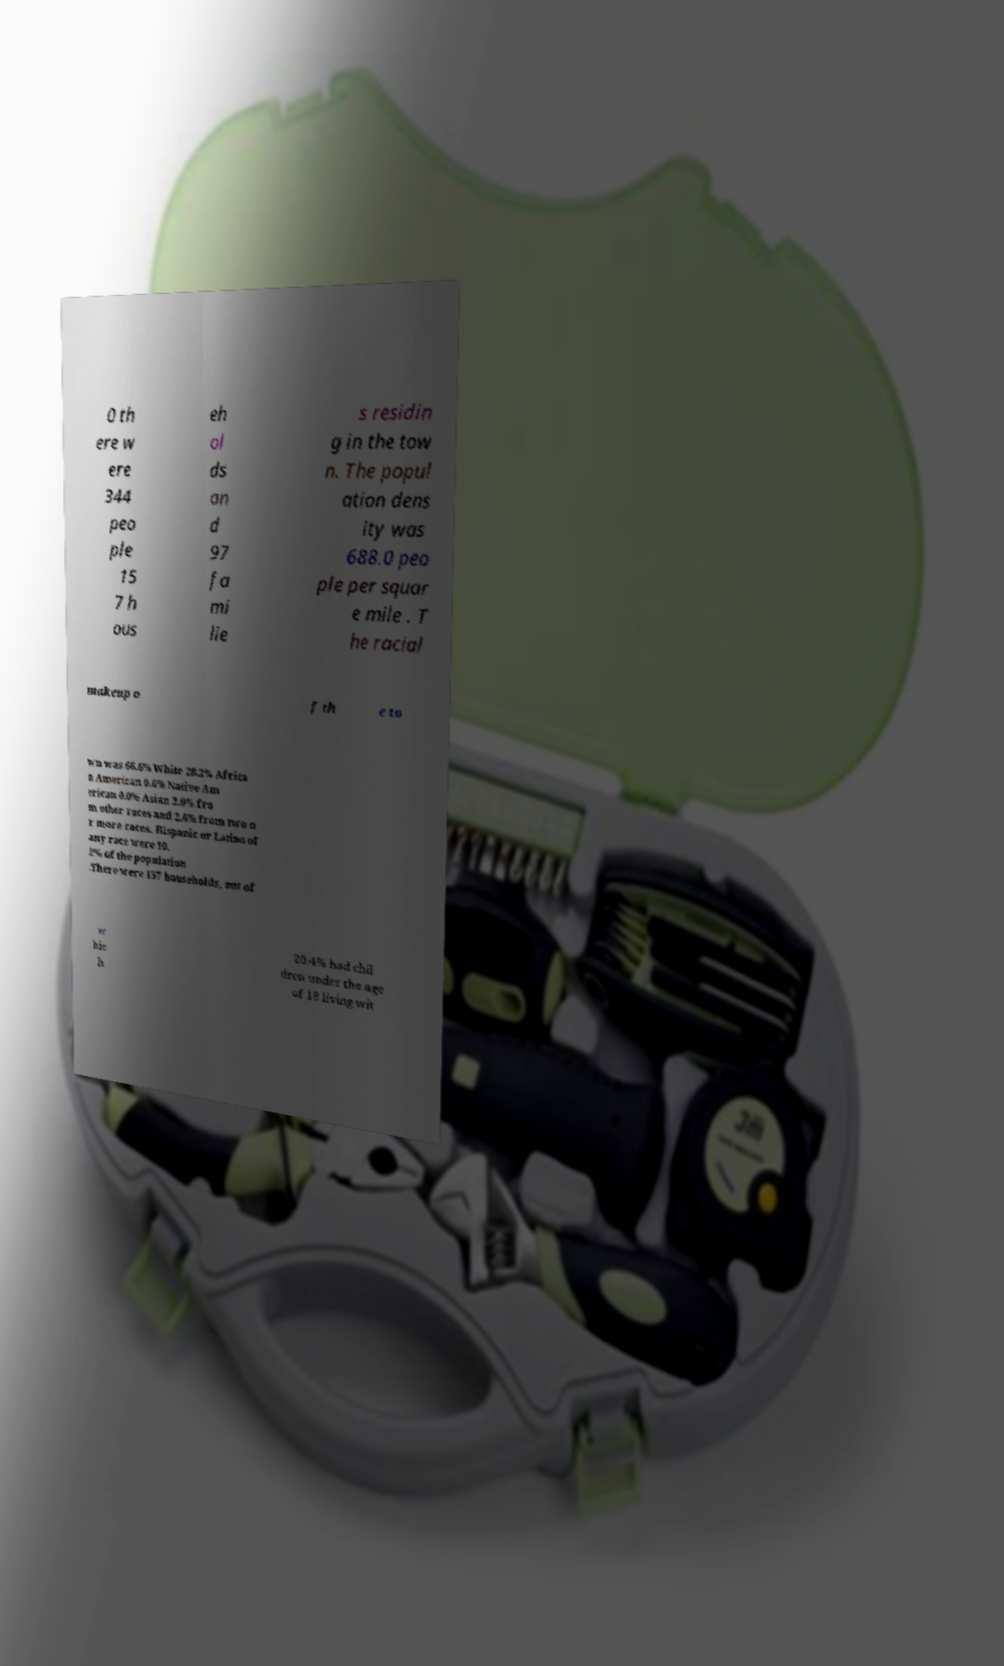Please read and relay the text visible in this image. What does it say? 0 th ere w ere 344 peo ple 15 7 h ous eh ol ds an d 97 fa mi lie s residin g in the tow n. The popul ation dens ity was 688.0 peo ple per squar e mile . T he racial makeup o f th e to wn was 66.6% White 28.2% Africa n American 0.6% Native Am erican 0.0% Asian 2.0% fro m other races and 2.6% from two o r more races. Hispanic or Latino of any race were 10. 2% of the population .There were 157 households, out of w hic h 20.4% had chil dren under the age of 18 living wit 